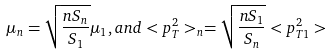<formula> <loc_0><loc_0><loc_500><loc_500>\mu _ { n } = \sqrt { \frac { n S _ { n } } { S _ { 1 } } } \mu _ { 1 } , a n d < p _ { T } ^ { 2 } > _ { n } = \sqrt { \frac { n S _ { 1 } } { S _ { n } } } < p _ { T 1 } ^ { 2 } ></formula> 